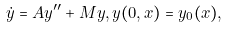Convert formula to latex. <formula><loc_0><loc_0><loc_500><loc_500>\dot { y } = A y ^ { \prime \prime } + M y , y ( 0 , x ) = y _ { 0 } ( x ) ,</formula> 